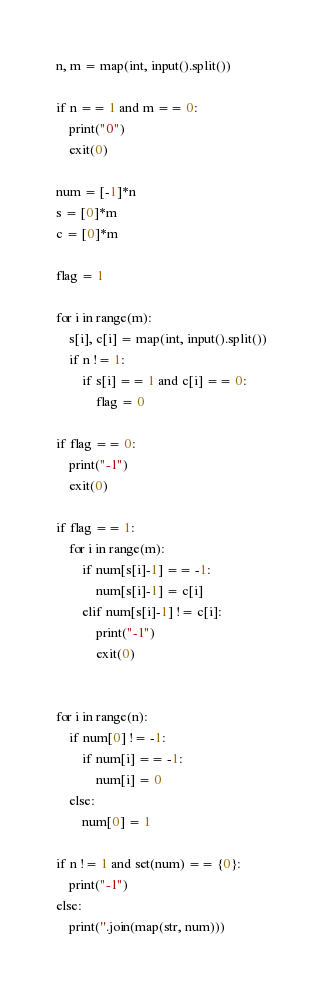Convert code to text. <code><loc_0><loc_0><loc_500><loc_500><_Python_>n, m = map(int, input().split())

if n == 1 and m == 0:
    print("0")
    exit(0)
    
num = [-1]*n
s = [0]*m
c = [0]*m

flag = 1

for i in range(m):
    s[i], c[i] = map(int, input().split())
    if n != 1:
        if s[i] == 1 and c[i] == 0:
            flag = 0

if flag == 0:
    print("-1")
    exit(0)

if flag == 1:
    for i in range(m):
        if num[s[i]-1] == -1:
            num[s[i]-1] = c[i]
        elif num[s[i]-1] != c[i]:
            print("-1")
            exit(0)


for i in range(n):
    if num[0] != -1:
        if num[i] == -1:
            num[i] = 0
    else:
        num[0] = 1

if n != 1 and set(num) == {0}:
    print("-1")
else:
    print(''.join(map(str, num)))
</code> 